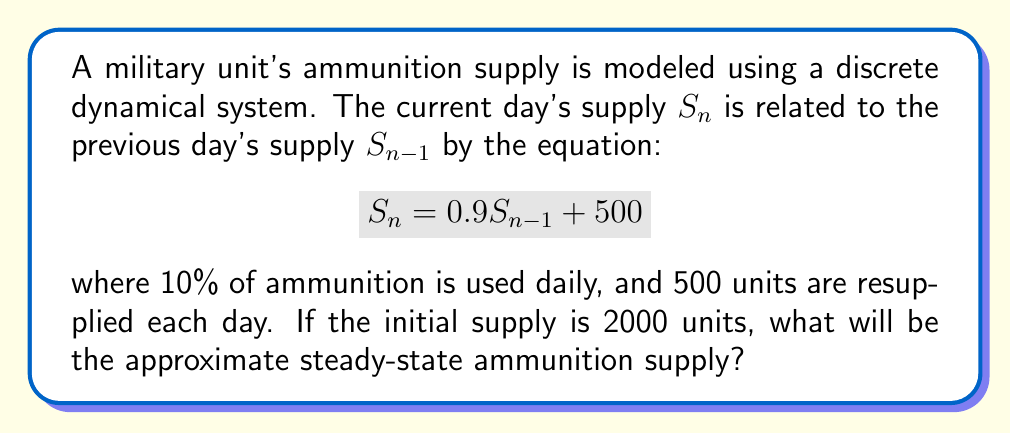Provide a solution to this math problem. To find the steady-state supply, we need to follow these steps:

1) In a steady state, the supply remains constant. This means $S_n = S_{n-1}$. Let's call this steady-state value $S^*$.

2) Substitute this into our equation:
   $$S^* = 0.9S^* + 500$$

3) Solve for $S^*$:
   $$S^* - 0.9S^* = 500$$
   $$0.1S^* = 500$$

4) Divide both sides by 0.1:
   $$S^* = \frac{500}{0.1} = 5000$$

5) Therefore, the steady-state supply is 5000 units.

To verify, we can check:
$$5000 = 0.9(5000) + 500$$
$$5000 = 4500 + 500$$
$$5000 = 5000$$

This confirms that 5000 units is indeed the steady-state supply.
Answer: 5000 units 